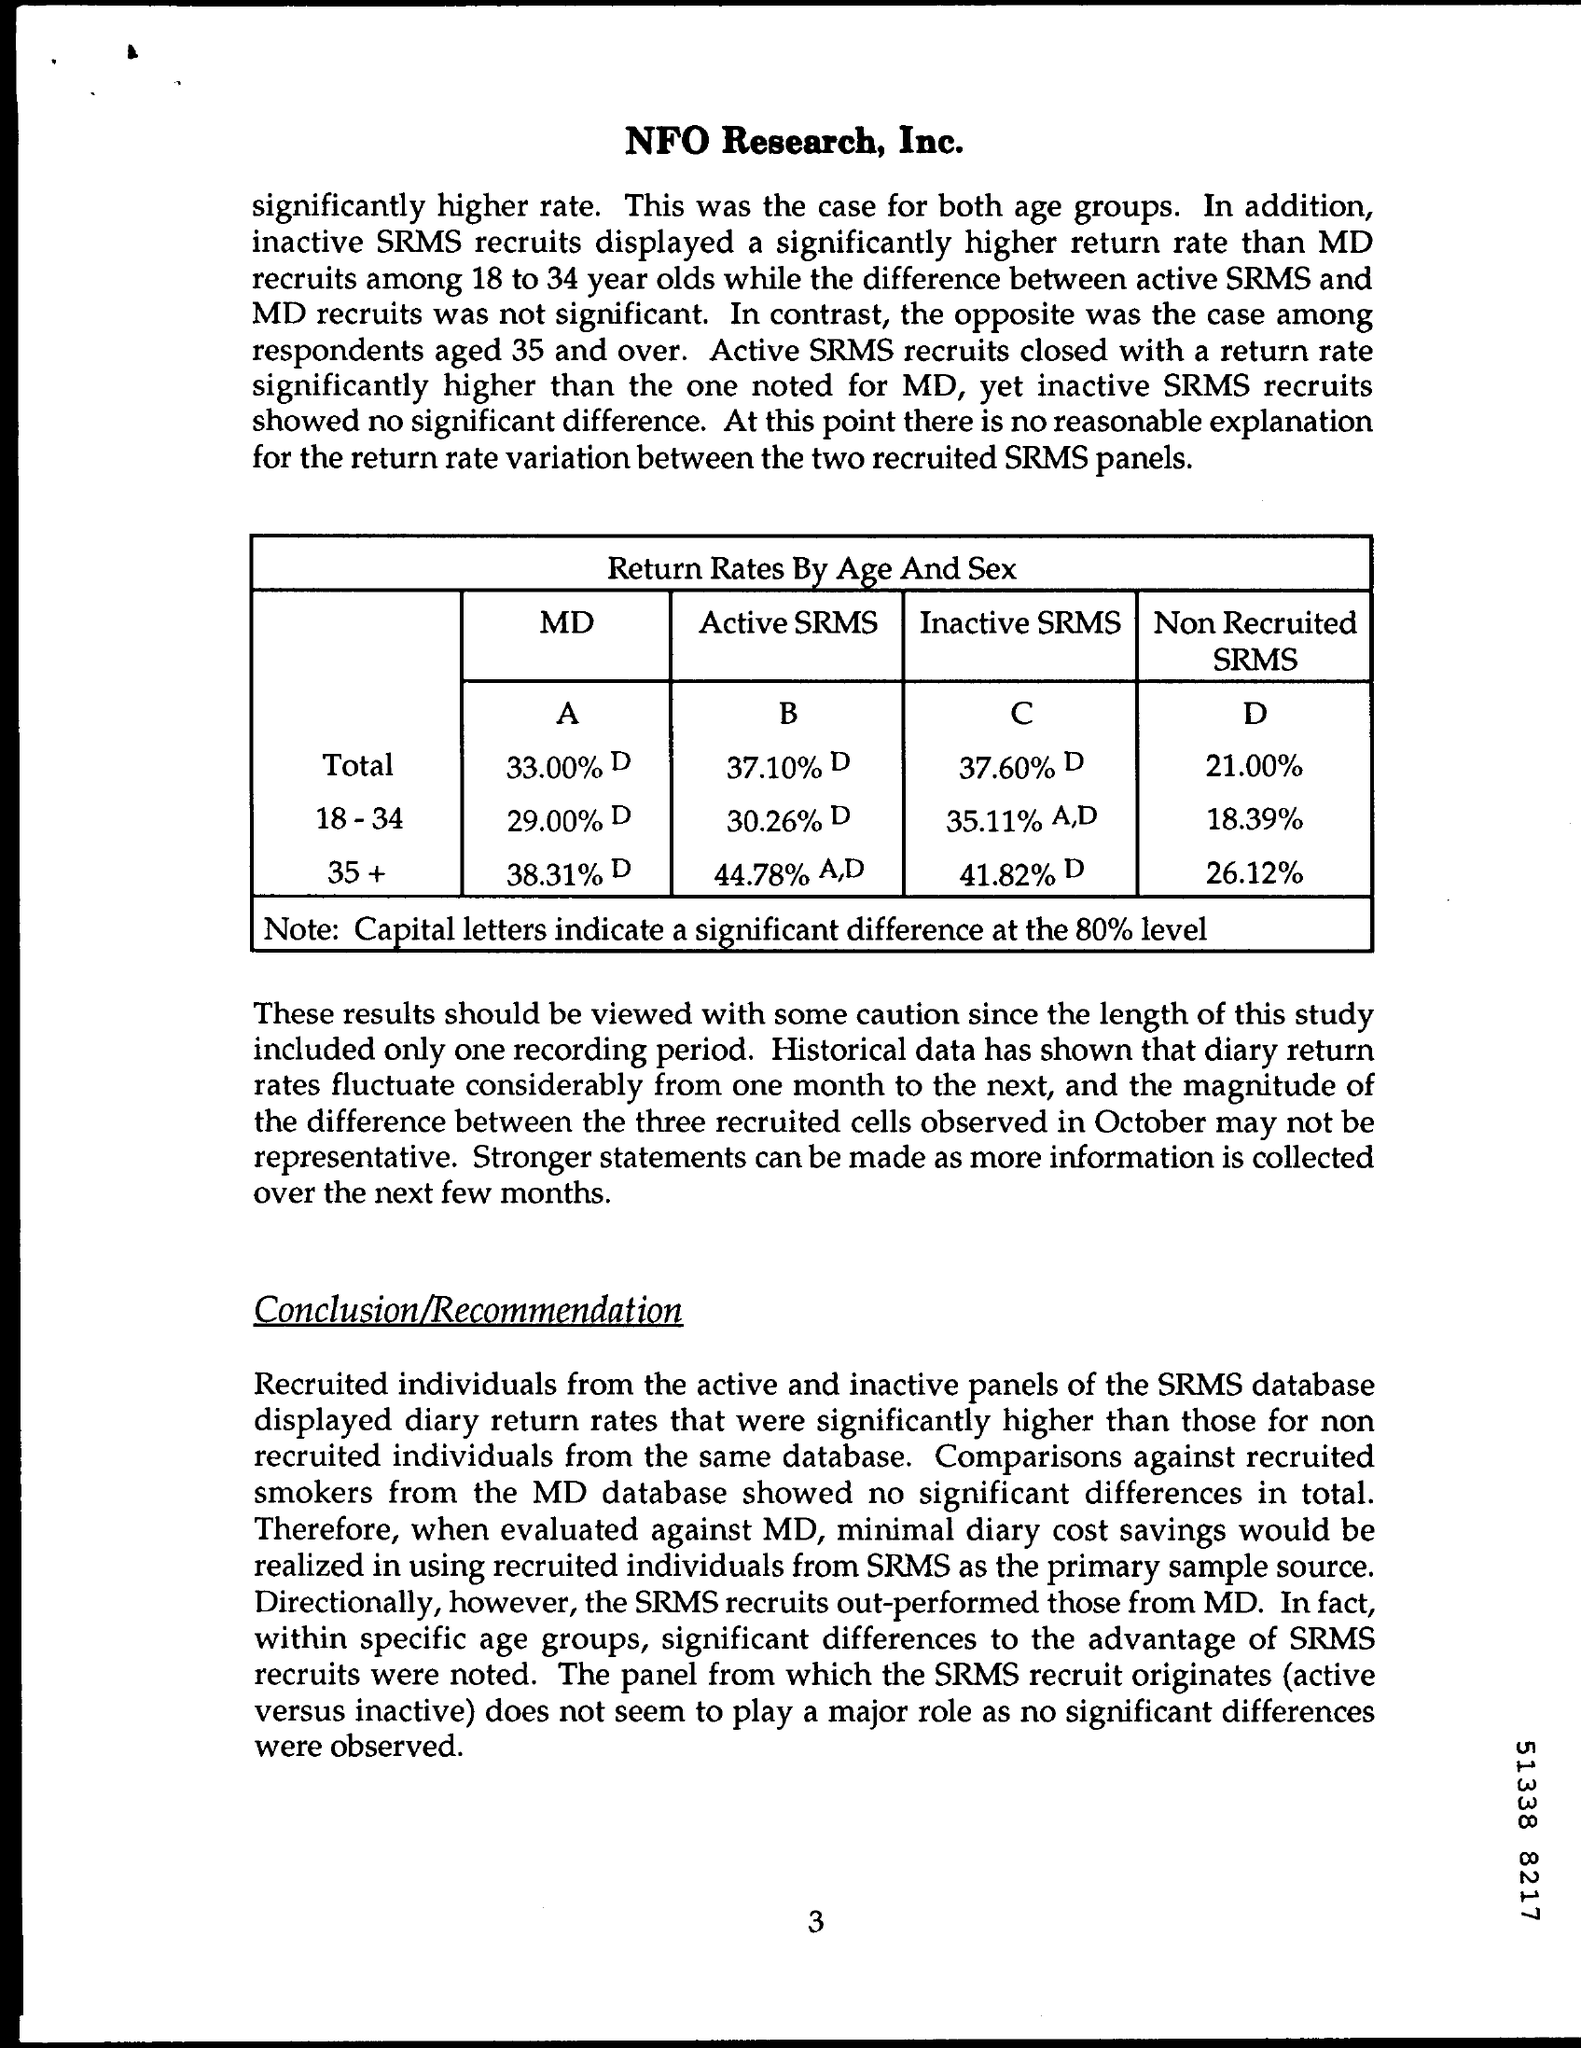What is the title of the table given?
Your answer should be very brief. Return Rates By Age and Sex. What is written at the top of the page?
Give a very brief answer. NFO Research, Inc. What is the page number on this document?
Make the answer very short. 3. What is the Non Recruited SRMS of ages 18-34?
Your answer should be very brief. 18.39%. 